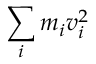<formula> <loc_0><loc_0><loc_500><loc_500>\sum _ { i } m _ { i } v _ { i } ^ { 2 }</formula> 